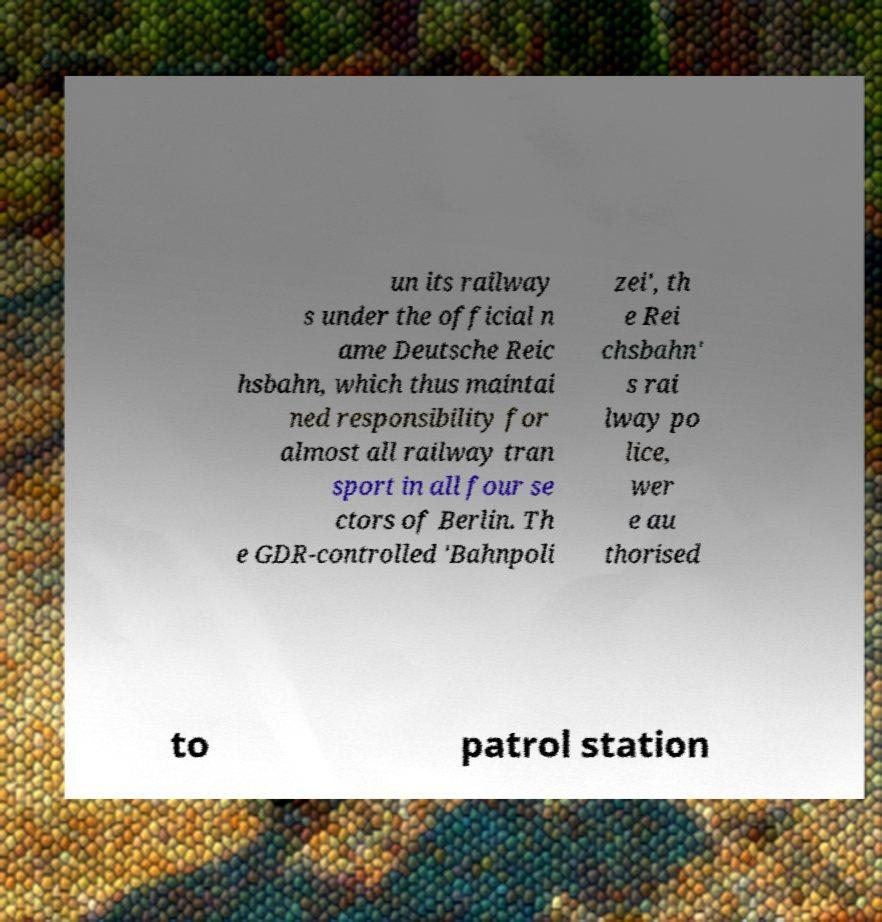What messages or text are displayed in this image? I need them in a readable, typed format. un its railway s under the official n ame Deutsche Reic hsbahn, which thus maintai ned responsibility for almost all railway tran sport in all four se ctors of Berlin. Th e GDR-controlled 'Bahnpoli zei', th e Rei chsbahn' s rai lway po lice, wer e au thorised to patrol station 